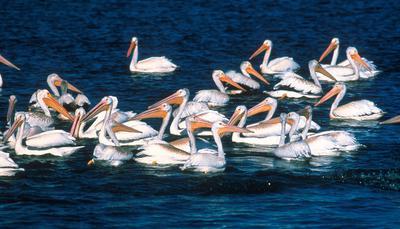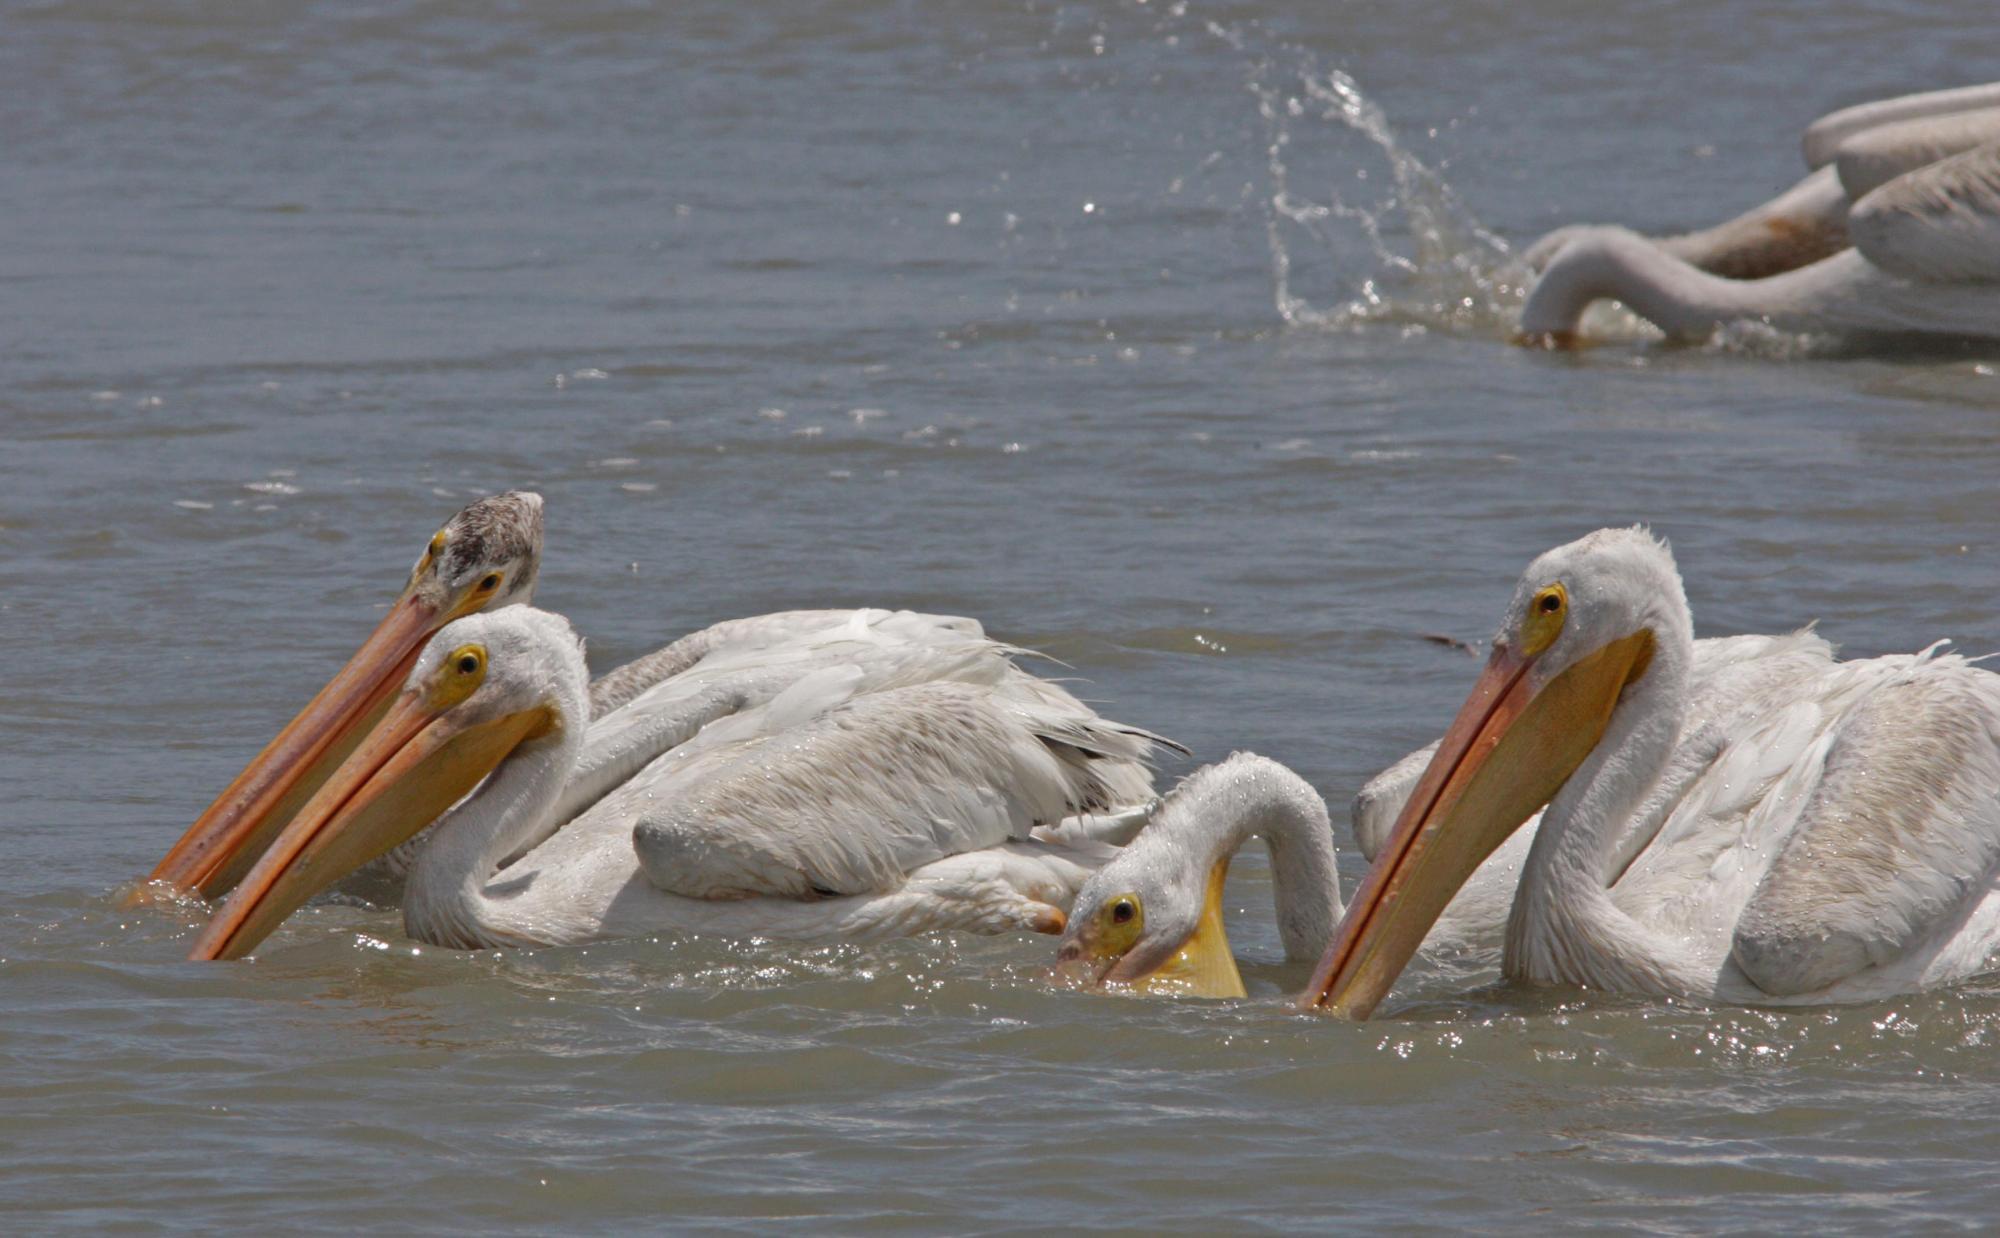The first image is the image on the left, the second image is the image on the right. Assess this claim about the two images: "Multiple birds are in flight in one image.". Correct or not? Answer yes or no. No. The first image is the image on the left, the second image is the image on the right. Assess this claim about the two images: "Some of the birds are standing in the water.". Correct or not? Answer yes or no. No. 